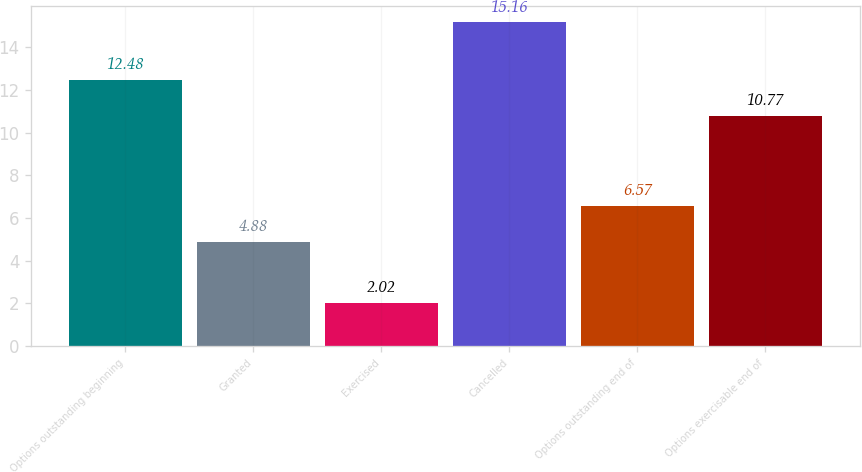<chart> <loc_0><loc_0><loc_500><loc_500><bar_chart><fcel>Options outstanding beginning<fcel>Granted<fcel>Exercised<fcel>Cancelled<fcel>Options outstanding end of<fcel>Options exercisable end of<nl><fcel>12.48<fcel>4.88<fcel>2.02<fcel>15.16<fcel>6.57<fcel>10.77<nl></chart> 